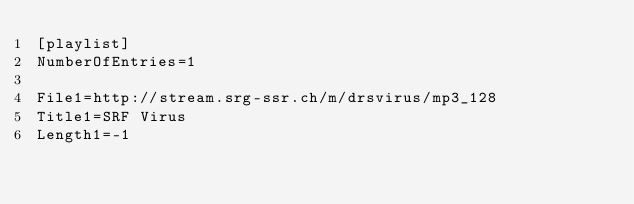Convert code to text. <code><loc_0><loc_0><loc_500><loc_500><_SQL_>[playlist]
NumberOfEntries=1

File1=http://stream.srg-ssr.ch/m/drsvirus/mp3_128
Title1=SRF Virus
Length1=-1
</code> 